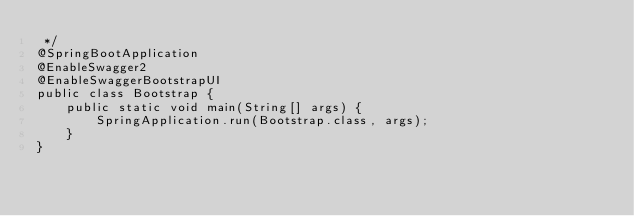<code> <loc_0><loc_0><loc_500><loc_500><_Java_> */
@SpringBootApplication
@EnableSwagger2
@EnableSwaggerBootstrapUI
public class Bootstrap {
    public static void main(String[] args) {
        SpringApplication.run(Bootstrap.class, args);
    }
}
</code> 